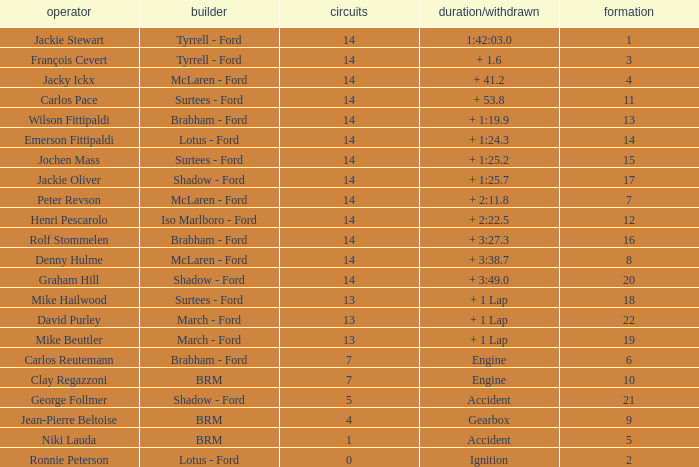What is the low lap total for henri pescarolo with a grad larger than 6? 14.0. 